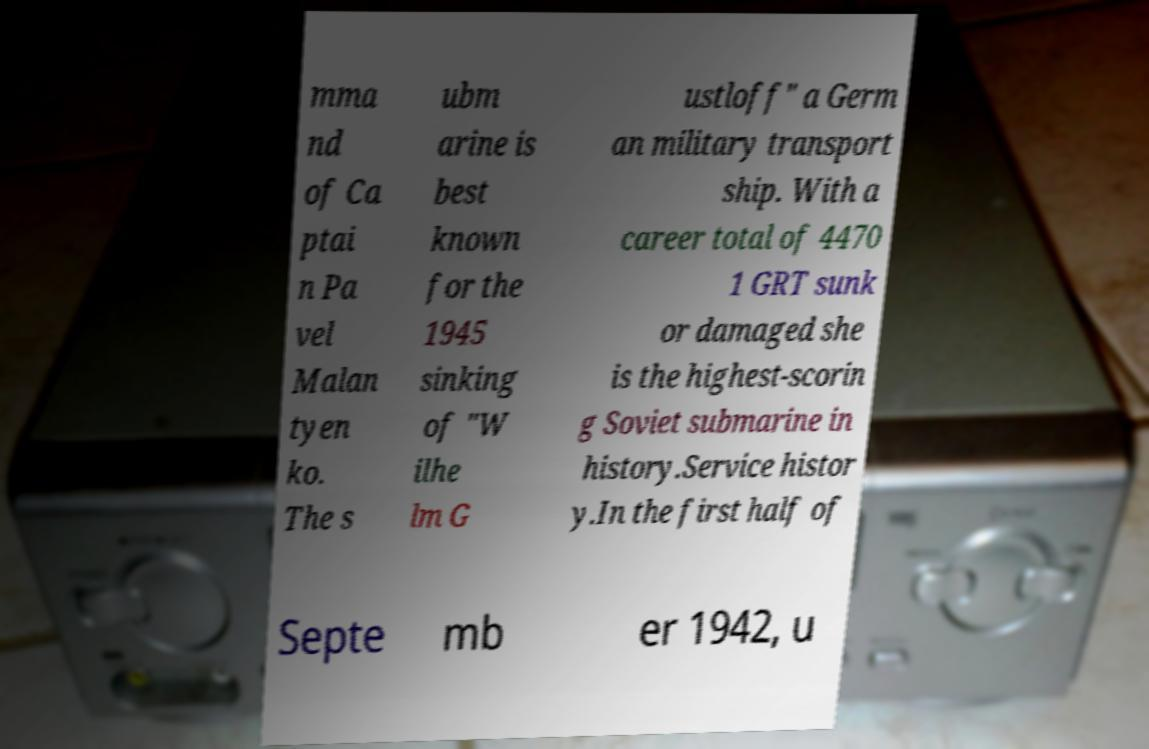Can you accurately transcribe the text from the provided image for me? mma nd of Ca ptai n Pa vel Malan tyen ko. The s ubm arine is best known for the 1945 sinking of "W ilhe lm G ustloff" a Germ an military transport ship. With a career total of 4470 1 GRT sunk or damaged she is the highest-scorin g Soviet submarine in history.Service histor y.In the first half of Septe mb er 1942, u 